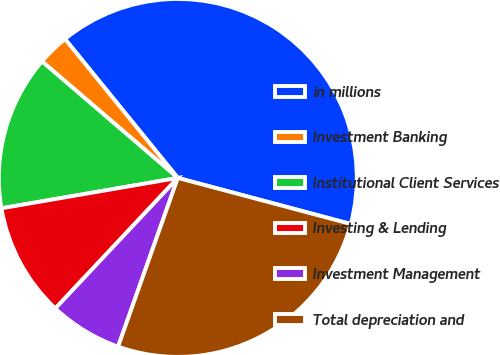<chart> <loc_0><loc_0><loc_500><loc_500><pie_chart><fcel>in millions<fcel>Investment Banking<fcel>Institutional Client Services<fcel>Investing & Lending<fcel>Investment Management<fcel>Total depreciation and<nl><fcel>40.0%<fcel>2.86%<fcel>14.0%<fcel>10.29%<fcel>6.58%<fcel>26.27%<nl></chart> 